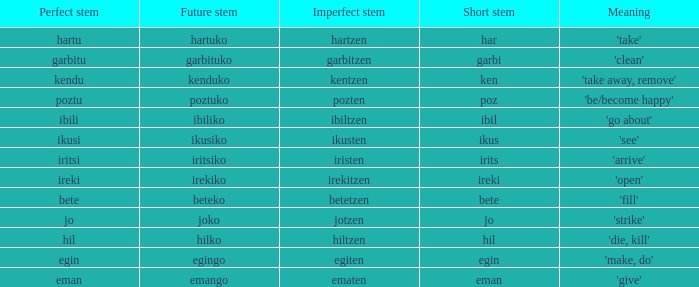For poztu, what is the future stem's numerical value? 1.0. 